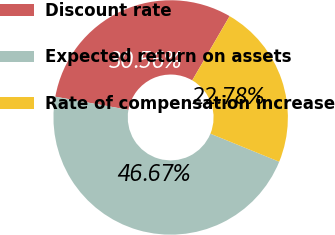Convert chart. <chart><loc_0><loc_0><loc_500><loc_500><pie_chart><fcel>Discount rate<fcel>Expected return on assets<fcel>Rate of compensation increase<nl><fcel>30.56%<fcel>46.67%<fcel>22.78%<nl></chart> 